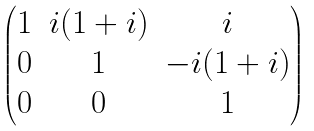Convert formula to latex. <formula><loc_0><loc_0><loc_500><loc_500>\begin{pmatrix} 1 & i ( 1 + i ) & i \\ 0 & 1 & - i ( 1 + i ) \\ 0 & 0 & 1 \end{pmatrix}</formula> 